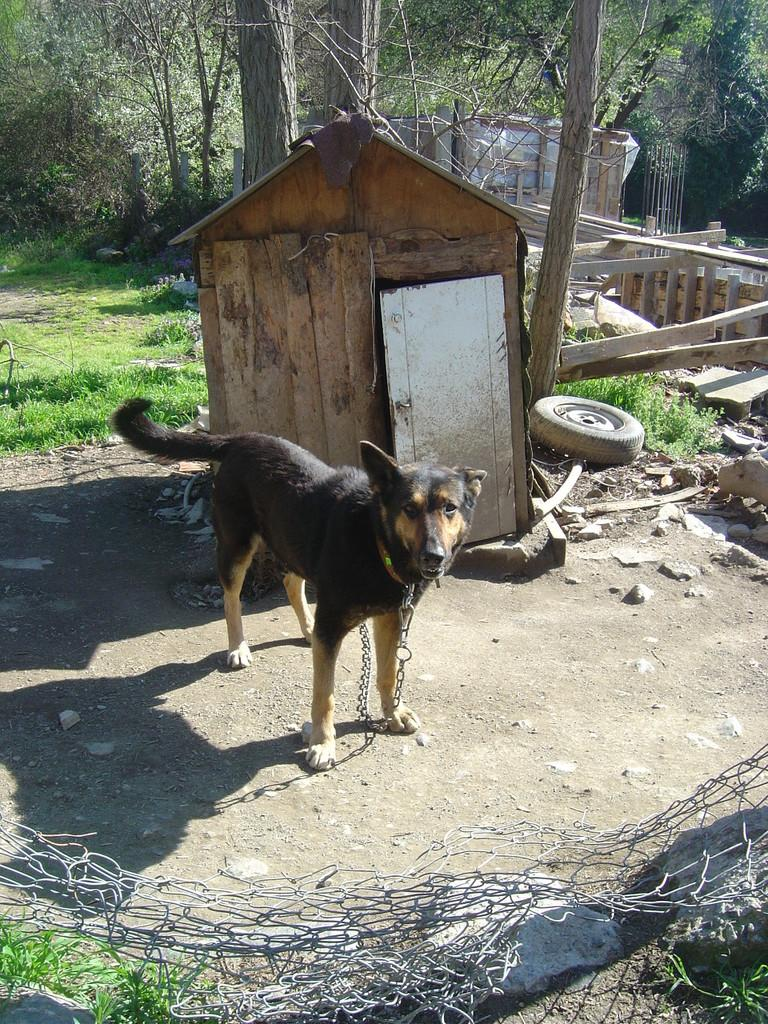What type of animal is in the image? There is a dog in the image. What structure is located behind the dog? There is a dog house behind the dog. What can be seen beside the dog house? There are waste objects beside the dog house. What type of vegetation is visible in the background of the image? There are trees in the background of the image. What type of ground surface is visible in the background of the image? There is grass visible in the background of the image. What type of haircut does the person in the image have? There is no person present in the image, only a dog and its surroundings. 